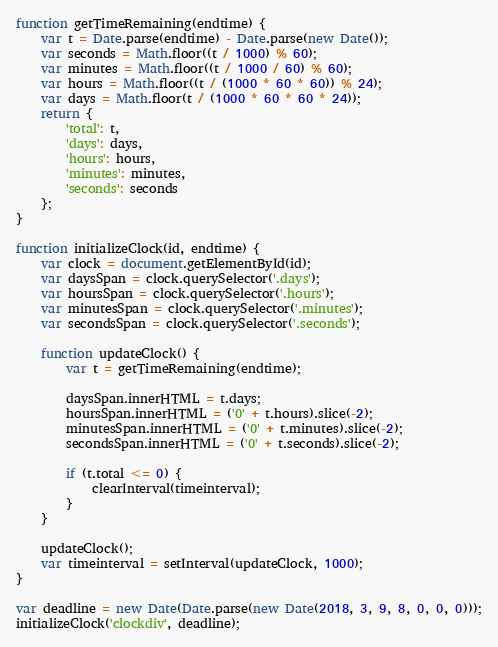<code> <loc_0><loc_0><loc_500><loc_500><_JavaScript_>function getTimeRemaining(endtime) {
    var t = Date.parse(endtime) - Date.parse(new Date());
    var seconds = Math.floor((t / 1000) % 60);
    var minutes = Math.floor((t / 1000 / 60) % 60);
    var hours = Math.floor((t / (1000 * 60 * 60)) % 24);
    var days = Math.floor(t / (1000 * 60 * 60 * 24));
    return {
        'total': t,
        'days': days,
        'hours': hours,
        'minutes': minutes,
        'seconds': seconds
    };
}

function initializeClock(id, endtime) {
    var clock = document.getElementById(id);
    var daysSpan = clock.querySelector('.days');
    var hoursSpan = clock.querySelector('.hours');
    var minutesSpan = clock.querySelector('.minutes');
    var secondsSpan = clock.querySelector('.seconds');

    function updateClock() {
        var t = getTimeRemaining(endtime);

        daysSpan.innerHTML = t.days;
        hoursSpan.innerHTML = ('0' + t.hours).slice(-2);
        minutesSpan.innerHTML = ('0' + t.minutes).slice(-2);
        secondsSpan.innerHTML = ('0' + t.seconds).slice(-2);

        if (t.total <= 0) {
            clearInterval(timeinterval);
        }
    }

    updateClock();
    var timeinterval = setInterval(updateClock, 1000);
}

var deadline = new Date(Date.parse(new Date(2018, 3, 9, 8, 0, 0, 0)));
initializeClock('clockdiv', deadline);</code> 